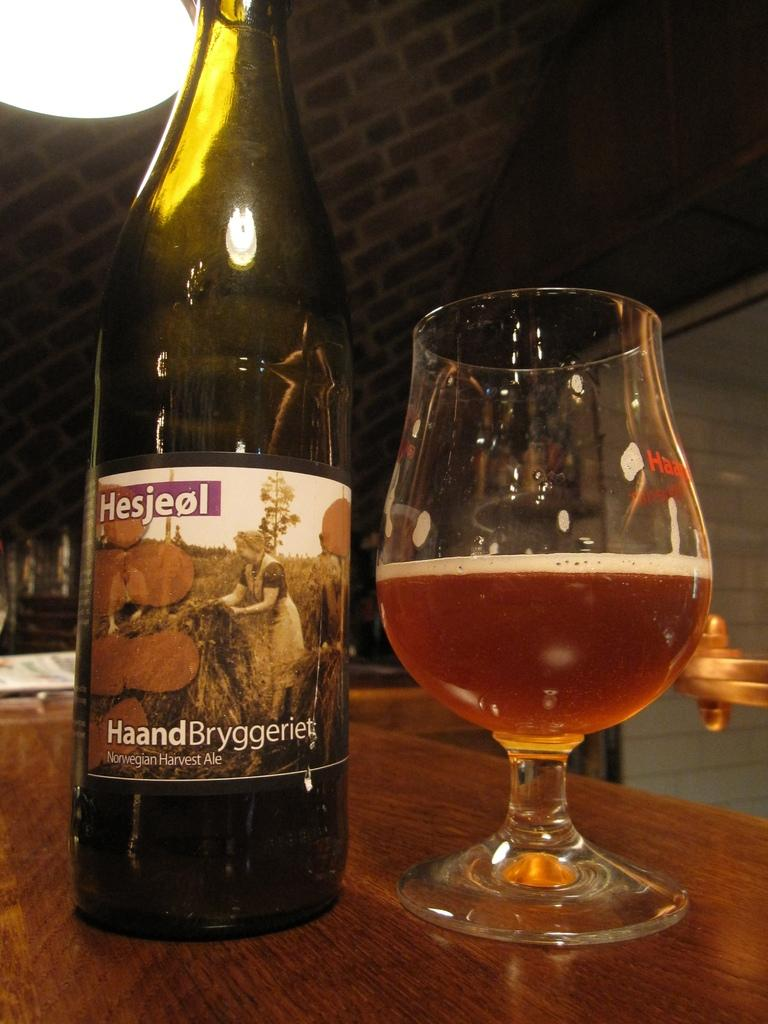<image>
Provide a brief description of the given image. Bottle of Hesjeol beer next to a half cup of beer. 